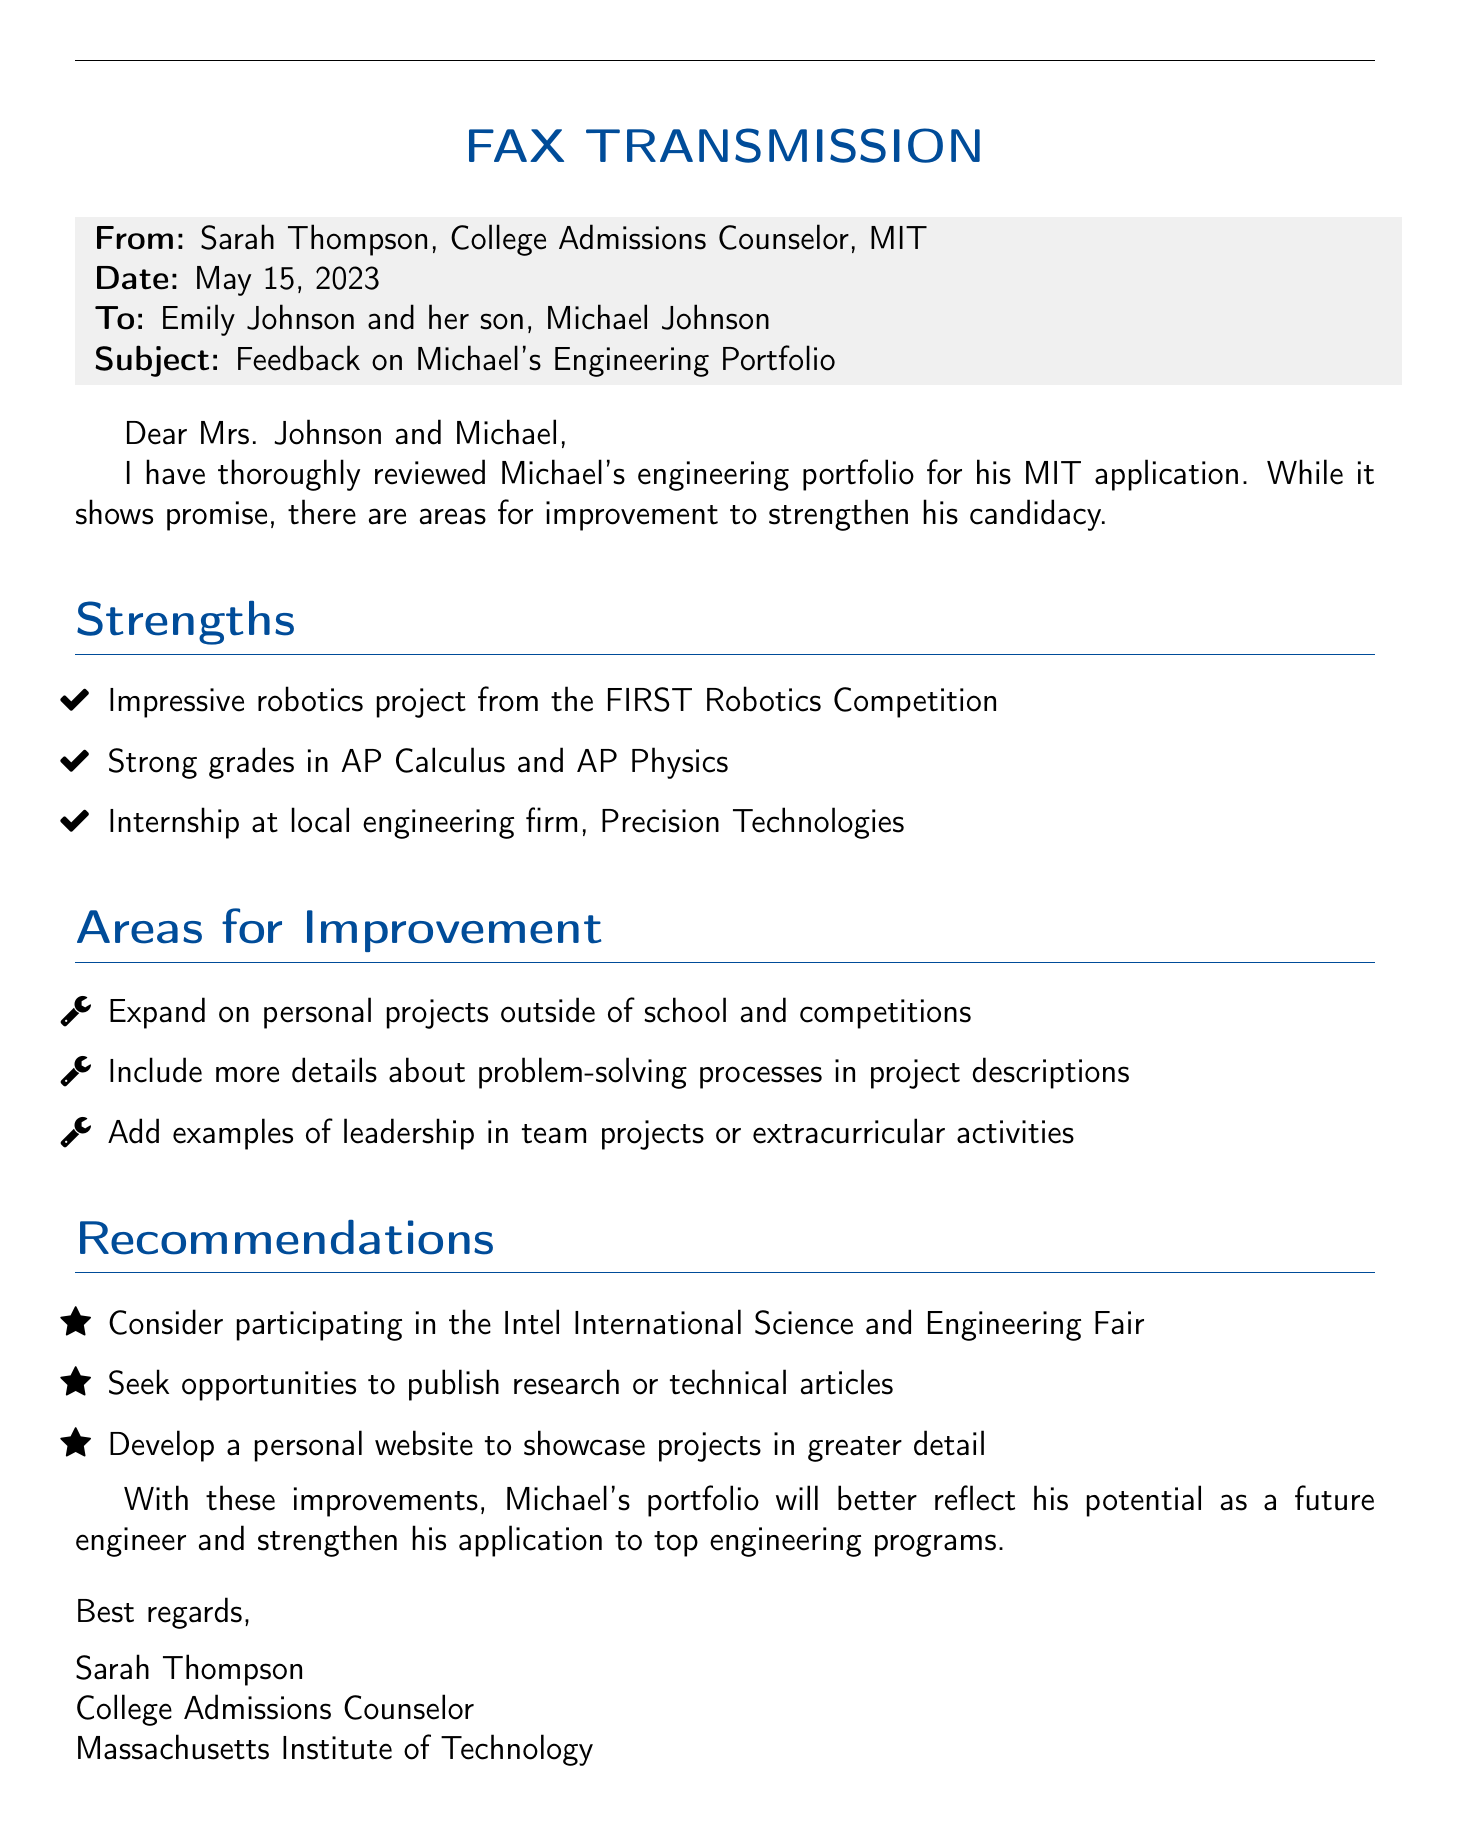What is the date of the feedback? The date of the feedback is specified at the top of the document as May 15, 2023.
Answer: May 15, 2023 Who is the college admissions counselor? The counselor's name is mentioned in the "From" section of the fax as Sarah Thompson.
Answer: Sarah Thompson What is one of Michael's strengths? The document lists several strengths, one being an impressive robotics project from the FIRST Robotics Competition.
Answer: Impressive robotics project from the FIRST Robotics Competition What is one area for improvement mentioned? The document highlights areas for improvement, including expanding on personal projects outside of school and competitions.
Answer: Expand on personal projects outside of school and competitions What is a recommended activity for Michael? The recommendations section suggests he consider participating in the Intel International Science and Engineering Fair.
Answer: Intel International Science and Engineering Fair What internship did Michael complete? The internship section of the document mentions an internship at a local engineering firm called Precision Technologies.
Answer: Precision Technologies How many strengths are mentioned in the document? The "Strengths" section lists three specific strengths related to Michael’s performance and projects.
Answer: Three What is one suggestion for showcasing projects? The recommendations section includes developing a personal website to showcase projects in greater detail.
Answer: Develop a personal website to showcase projects in greater detail What type of document is this? The title at the top indicates that this is a fax transmission.
Answer: Fax transmission 